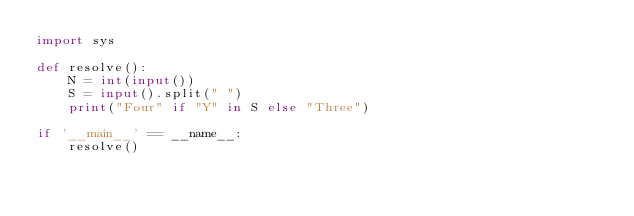<code> <loc_0><loc_0><loc_500><loc_500><_Python_>import sys

def resolve():
    N = int(input())
    S = input().split(" ")
    print("Four" if "Y" in S else "Three")

if '__main__' == __name__:
    resolve()</code> 